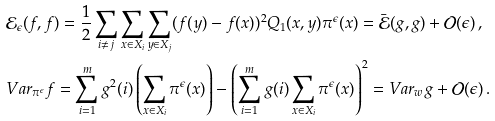Convert formula to latex. <formula><loc_0><loc_0><loc_500><loc_500>& \mathcal { E } _ { \epsilon } ( f , f ) = \frac { 1 } { 2 } \sum _ { i \neq j } \sum _ { x \in X _ { i } } \sum _ { y \in X _ { j } } ( f ( y ) - f ( x ) ) ^ { 2 } Q _ { 1 } ( x , y ) \pi ^ { \epsilon } ( x ) = \bar { \mathcal { E } } ( g , g ) + \mathcal { O } ( \epsilon ) \, , \\ & V a r _ { \pi ^ { \epsilon } } f = \sum _ { i = 1 } ^ { m } g ^ { 2 } ( i ) \left ( \sum _ { x \in X _ { i } } \pi ^ { \epsilon } ( x ) \right ) - \left ( \sum _ { i = 1 } ^ { m } g ( i ) \sum _ { x \in X _ { i } } \pi ^ { \epsilon } ( x ) \right ) ^ { 2 } = V a r _ { w } g + \mathcal { O } ( \epsilon ) \, .</formula> 